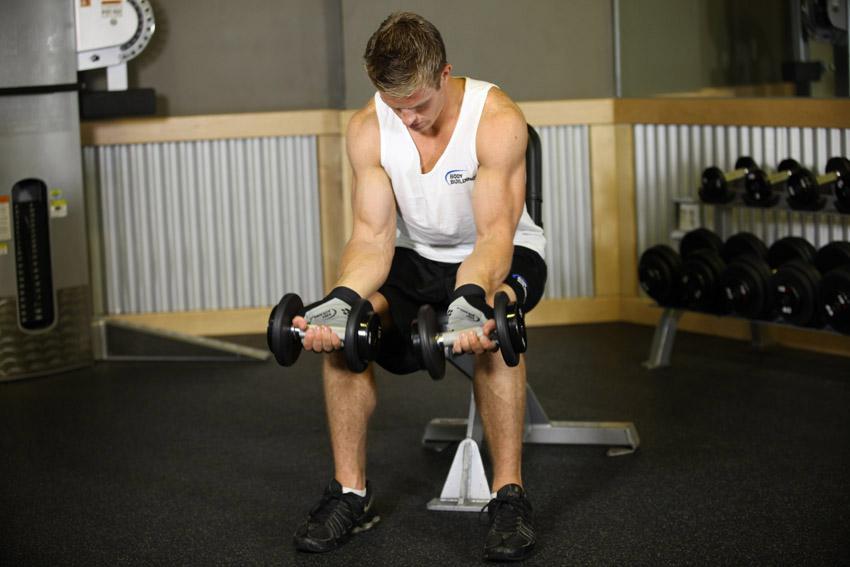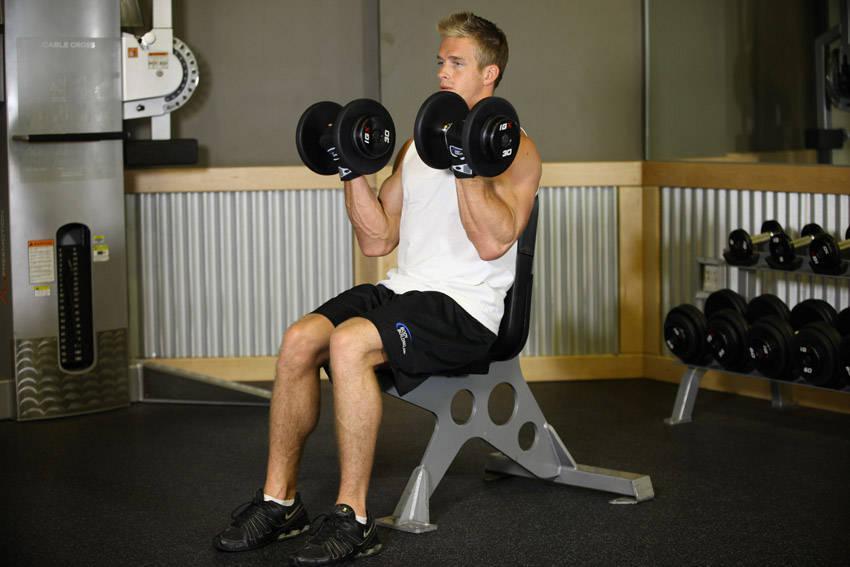The first image is the image on the left, the second image is the image on the right. Analyze the images presented: Is the assertion "At least one woman is featured." valid? Answer yes or no. No. 